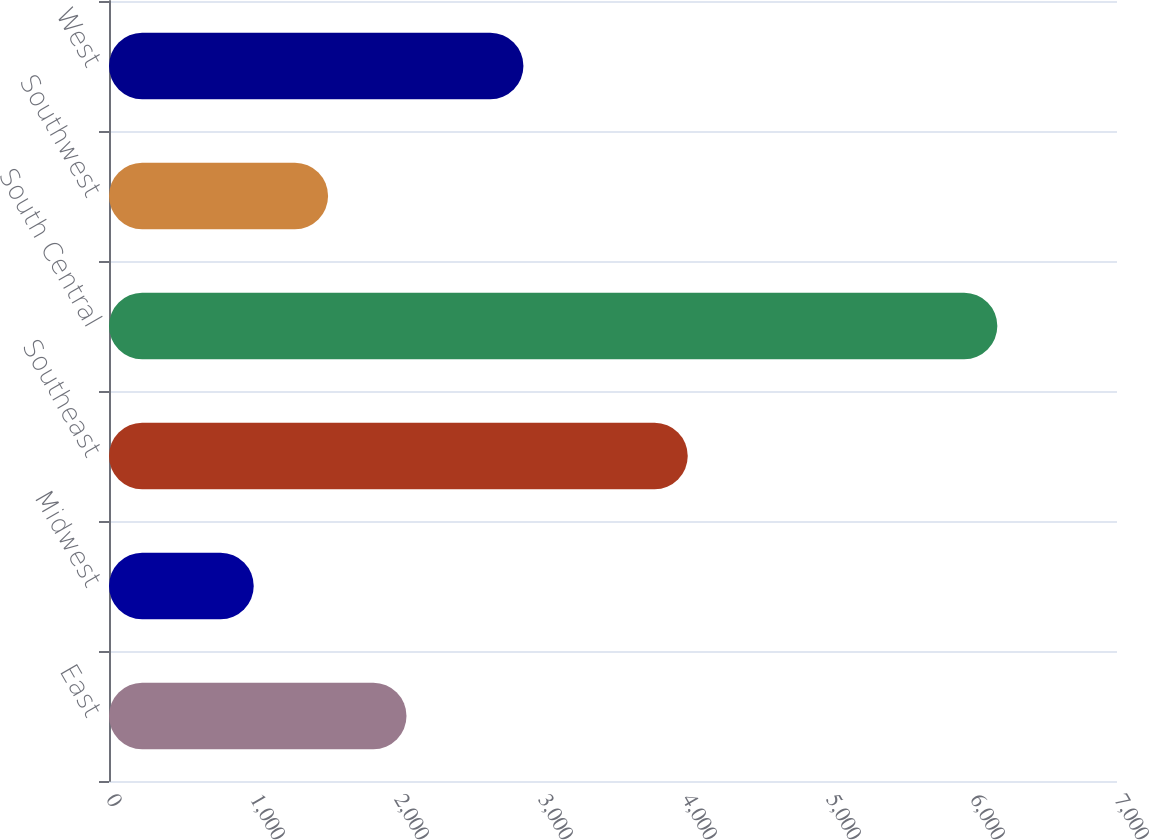<chart> <loc_0><loc_0><loc_500><loc_500><bar_chart><fcel>East<fcel>Midwest<fcel>Southeast<fcel>South Central<fcel>Southwest<fcel>West<nl><fcel>2066<fcel>1005<fcel>4019<fcel>6169<fcel>1521.4<fcel>2878<nl></chart> 